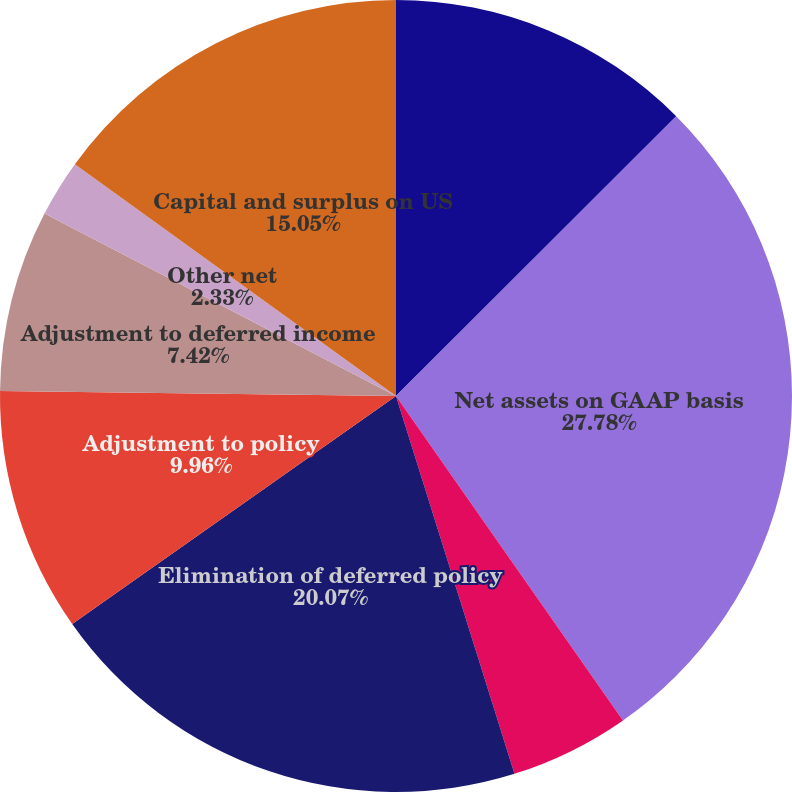Convert chart to OTSL. <chart><loc_0><loc_0><loc_500><loc_500><pie_chart><fcel>(In millions)<fcel>Net assets on GAAP basis<fcel>Adjustment of carrying values<fcel>Elimination of deferred policy<fcel>Adjustment to policy<fcel>Adjustment to deferred income<fcel>Other net<fcel>Capital and surplus on US<nl><fcel>12.51%<fcel>27.77%<fcel>4.88%<fcel>20.07%<fcel>9.96%<fcel>7.42%<fcel>2.33%<fcel>15.05%<nl></chart> 